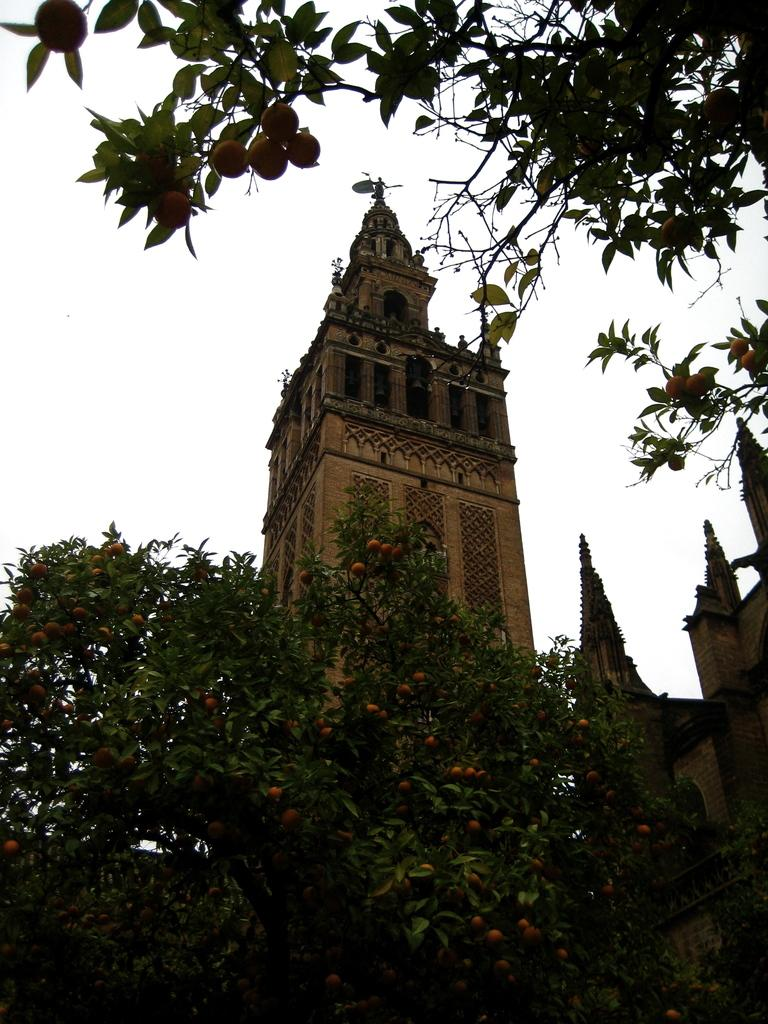What type of vegetation can be seen on the tree in the image? There are fruits on the tree in the image. What type of structure is present in the image? There is a building in the image. What is the condition of the sky in the image? The sky is clear in the image. What type of leather can be seen hanging from the tree in the image? There is no leather present in the image; it features fruits on the tree. Can you describe the view from the building in the image? The provided facts do not mention a view from the building, so we cannot describe it. 